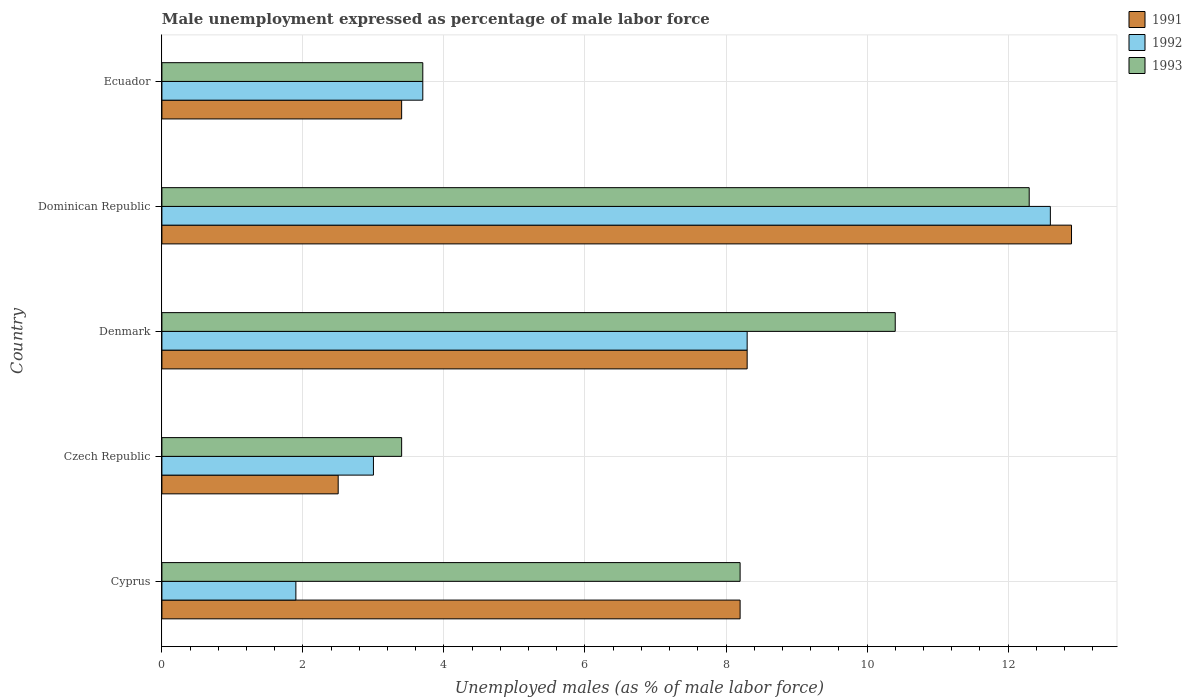How many different coloured bars are there?
Give a very brief answer. 3. How many bars are there on the 3rd tick from the bottom?
Make the answer very short. 3. What is the label of the 2nd group of bars from the top?
Provide a short and direct response. Dominican Republic. What is the unemployment in males in in 1992 in Cyprus?
Make the answer very short. 1.9. Across all countries, what is the maximum unemployment in males in in 1993?
Give a very brief answer. 12.3. In which country was the unemployment in males in in 1993 maximum?
Ensure brevity in your answer.  Dominican Republic. In which country was the unemployment in males in in 1993 minimum?
Provide a succinct answer. Czech Republic. What is the total unemployment in males in in 1992 in the graph?
Your response must be concise. 29.5. What is the difference between the unemployment in males in in 1991 in Denmark and that in Ecuador?
Give a very brief answer. 4.9. What is the difference between the unemployment in males in in 1993 in Czech Republic and the unemployment in males in in 1992 in Ecuador?
Make the answer very short. -0.3. What is the average unemployment in males in in 1993 per country?
Your answer should be very brief. 7.6. What is the difference between the unemployment in males in in 1991 and unemployment in males in in 1992 in Dominican Republic?
Offer a very short reply. 0.3. What is the ratio of the unemployment in males in in 1993 in Cyprus to that in Denmark?
Ensure brevity in your answer.  0.79. Is the unemployment in males in in 1993 in Denmark less than that in Ecuador?
Provide a short and direct response. No. What is the difference between the highest and the second highest unemployment in males in in 1993?
Ensure brevity in your answer.  1.9. What is the difference between the highest and the lowest unemployment in males in in 1993?
Provide a short and direct response. 8.9. Is the sum of the unemployment in males in in 1992 in Cyprus and Ecuador greater than the maximum unemployment in males in in 1993 across all countries?
Offer a very short reply. No. Is it the case that in every country, the sum of the unemployment in males in in 1991 and unemployment in males in in 1992 is greater than the unemployment in males in in 1993?
Keep it short and to the point. Yes. What is the difference between two consecutive major ticks on the X-axis?
Your response must be concise. 2. Where does the legend appear in the graph?
Offer a very short reply. Top right. What is the title of the graph?
Offer a very short reply. Male unemployment expressed as percentage of male labor force. What is the label or title of the X-axis?
Provide a succinct answer. Unemployed males (as % of male labor force). What is the Unemployed males (as % of male labor force) of 1991 in Cyprus?
Provide a short and direct response. 8.2. What is the Unemployed males (as % of male labor force) of 1992 in Cyprus?
Keep it short and to the point. 1.9. What is the Unemployed males (as % of male labor force) in 1993 in Cyprus?
Give a very brief answer. 8.2. What is the Unemployed males (as % of male labor force) of 1991 in Czech Republic?
Keep it short and to the point. 2.5. What is the Unemployed males (as % of male labor force) of 1993 in Czech Republic?
Ensure brevity in your answer.  3.4. What is the Unemployed males (as % of male labor force) in 1991 in Denmark?
Your answer should be compact. 8.3. What is the Unemployed males (as % of male labor force) in 1992 in Denmark?
Your response must be concise. 8.3. What is the Unemployed males (as % of male labor force) of 1993 in Denmark?
Ensure brevity in your answer.  10.4. What is the Unemployed males (as % of male labor force) in 1991 in Dominican Republic?
Make the answer very short. 12.9. What is the Unemployed males (as % of male labor force) in 1992 in Dominican Republic?
Your response must be concise. 12.6. What is the Unemployed males (as % of male labor force) of 1993 in Dominican Republic?
Provide a succinct answer. 12.3. What is the Unemployed males (as % of male labor force) of 1991 in Ecuador?
Make the answer very short. 3.4. What is the Unemployed males (as % of male labor force) of 1992 in Ecuador?
Your answer should be very brief. 3.7. What is the Unemployed males (as % of male labor force) of 1993 in Ecuador?
Provide a short and direct response. 3.7. Across all countries, what is the maximum Unemployed males (as % of male labor force) of 1991?
Provide a succinct answer. 12.9. Across all countries, what is the maximum Unemployed males (as % of male labor force) in 1992?
Your answer should be compact. 12.6. Across all countries, what is the maximum Unemployed males (as % of male labor force) in 1993?
Your answer should be compact. 12.3. Across all countries, what is the minimum Unemployed males (as % of male labor force) in 1991?
Your answer should be very brief. 2.5. Across all countries, what is the minimum Unemployed males (as % of male labor force) in 1992?
Keep it short and to the point. 1.9. Across all countries, what is the minimum Unemployed males (as % of male labor force) in 1993?
Give a very brief answer. 3.4. What is the total Unemployed males (as % of male labor force) of 1991 in the graph?
Ensure brevity in your answer.  35.3. What is the total Unemployed males (as % of male labor force) in 1992 in the graph?
Keep it short and to the point. 29.5. What is the total Unemployed males (as % of male labor force) of 1993 in the graph?
Your answer should be compact. 38. What is the difference between the Unemployed males (as % of male labor force) of 1992 in Cyprus and that in Czech Republic?
Ensure brevity in your answer.  -1.1. What is the difference between the Unemployed males (as % of male labor force) in 1993 in Cyprus and that in Czech Republic?
Your response must be concise. 4.8. What is the difference between the Unemployed males (as % of male labor force) in 1991 in Cyprus and that in Denmark?
Your response must be concise. -0.1. What is the difference between the Unemployed males (as % of male labor force) in 1991 in Cyprus and that in Dominican Republic?
Your response must be concise. -4.7. What is the difference between the Unemployed males (as % of male labor force) in 1992 in Cyprus and that in Dominican Republic?
Make the answer very short. -10.7. What is the difference between the Unemployed males (as % of male labor force) of 1992 in Cyprus and that in Ecuador?
Offer a very short reply. -1.8. What is the difference between the Unemployed males (as % of male labor force) of 1993 in Cyprus and that in Ecuador?
Offer a terse response. 4.5. What is the difference between the Unemployed males (as % of male labor force) of 1991 in Czech Republic and that in Denmark?
Your answer should be very brief. -5.8. What is the difference between the Unemployed males (as % of male labor force) in 1993 in Czech Republic and that in Denmark?
Make the answer very short. -7. What is the difference between the Unemployed males (as % of male labor force) of 1991 in Czech Republic and that in Dominican Republic?
Give a very brief answer. -10.4. What is the difference between the Unemployed males (as % of male labor force) in 1993 in Czech Republic and that in Dominican Republic?
Offer a very short reply. -8.9. What is the difference between the Unemployed males (as % of male labor force) in 1993 in Czech Republic and that in Ecuador?
Offer a very short reply. -0.3. What is the difference between the Unemployed males (as % of male labor force) of 1992 in Denmark and that in Dominican Republic?
Keep it short and to the point. -4.3. What is the difference between the Unemployed males (as % of male labor force) in 1991 in Denmark and that in Ecuador?
Ensure brevity in your answer.  4.9. What is the difference between the Unemployed males (as % of male labor force) in 1992 in Denmark and that in Ecuador?
Your answer should be very brief. 4.6. What is the difference between the Unemployed males (as % of male labor force) of 1992 in Dominican Republic and that in Ecuador?
Ensure brevity in your answer.  8.9. What is the difference between the Unemployed males (as % of male labor force) of 1991 in Cyprus and the Unemployed males (as % of male labor force) of 1993 in Czech Republic?
Provide a succinct answer. 4.8. What is the difference between the Unemployed males (as % of male labor force) of 1992 in Cyprus and the Unemployed males (as % of male labor force) of 1993 in Czech Republic?
Keep it short and to the point. -1.5. What is the difference between the Unemployed males (as % of male labor force) of 1991 in Cyprus and the Unemployed males (as % of male labor force) of 1992 in Denmark?
Offer a terse response. -0.1. What is the difference between the Unemployed males (as % of male labor force) in 1991 in Cyprus and the Unemployed males (as % of male labor force) in 1993 in Denmark?
Offer a very short reply. -2.2. What is the difference between the Unemployed males (as % of male labor force) in 1991 in Cyprus and the Unemployed males (as % of male labor force) in 1992 in Dominican Republic?
Make the answer very short. -4.4. What is the difference between the Unemployed males (as % of male labor force) of 1991 in Czech Republic and the Unemployed males (as % of male labor force) of 1992 in Denmark?
Offer a very short reply. -5.8. What is the difference between the Unemployed males (as % of male labor force) in 1992 in Czech Republic and the Unemployed males (as % of male labor force) in 1993 in Denmark?
Keep it short and to the point. -7.4. What is the difference between the Unemployed males (as % of male labor force) of 1991 in Czech Republic and the Unemployed males (as % of male labor force) of 1992 in Dominican Republic?
Ensure brevity in your answer.  -10.1. What is the difference between the Unemployed males (as % of male labor force) in 1991 in Czech Republic and the Unemployed males (as % of male labor force) in 1993 in Dominican Republic?
Make the answer very short. -9.8. What is the difference between the Unemployed males (as % of male labor force) of 1992 in Czech Republic and the Unemployed males (as % of male labor force) of 1993 in Ecuador?
Ensure brevity in your answer.  -0.7. What is the difference between the Unemployed males (as % of male labor force) in 1991 in Denmark and the Unemployed males (as % of male labor force) in 1993 in Ecuador?
Keep it short and to the point. 4.6. What is the average Unemployed males (as % of male labor force) of 1991 per country?
Your response must be concise. 7.06. What is the average Unemployed males (as % of male labor force) of 1992 per country?
Give a very brief answer. 5.9. What is the average Unemployed males (as % of male labor force) in 1993 per country?
Provide a succinct answer. 7.6. What is the difference between the Unemployed males (as % of male labor force) in 1991 and Unemployed males (as % of male labor force) in 1993 in Denmark?
Your answer should be very brief. -2.1. What is the difference between the Unemployed males (as % of male labor force) of 1992 and Unemployed males (as % of male labor force) of 1993 in Denmark?
Your response must be concise. -2.1. What is the difference between the Unemployed males (as % of male labor force) in 1991 and Unemployed males (as % of male labor force) in 1992 in Dominican Republic?
Provide a short and direct response. 0.3. What is the difference between the Unemployed males (as % of male labor force) of 1991 and Unemployed males (as % of male labor force) of 1992 in Ecuador?
Provide a short and direct response. -0.3. What is the difference between the Unemployed males (as % of male labor force) of 1991 and Unemployed males (as % of male labor force) of 1993 in Ecuador?
Offer a very short reply. -0.3. What is the ratio of the Unemployed males (as % of male labor force) in 1991 in Cyprus to that in Czech Republic?
Provide a short and direct response. 3.28. What is the ratio of the Unemployed males (as % of male labor force) of 1992 in Cyprus to that in Czech Republic?
Keep it short and to the point. 0.63. What is the ratio of the Unemployed males (as % of male labor force) in 1993 in Cyprus to that in Czech Republic?
Your answer should be compact. 2.41. What is the ratio of the Unemployed males (as % of male labor force) of 1991 in Cyprus to that in Denmark?
Provide a succinct answer. 0.99. What is the ratio of the Unemployed males (as % of male labor force) in 1992 in Cyprus to that in Denmark?
Give a very brief answer. 0.23. What is the ratio of the Unemployed males (as % of male labor force) of 1993 in Cyprus to that in Denmark?
Your response must be concise. 0.79. What is the ratio of the Unemployed males (as % of male labor force) in 1991 in Cyprus to that in Dominican Republic?
Provide a succinct answer. 0.64. What is the ratio of the Unemployed males (as % of male labor force) in 1992 in Cyprus to that in Dominican Republic?
Ensure brevity in your answer.  0.15. What is the ratio of the Unemployed males (as % of male labor force) of 1991 in Cyprus to that in Ecuador?
Your answer should be compact. 2.41. What is the ratio of the Unemployed males (as % of male labor force) of 1992 in Cyprus to that in Ecuador?
Your answer should be very brief. 0.51. What is the ratio of the Unemployed males (as % of male labor force) of 1993 in Cyprus to that in Ecuador?
Provide a succinct answer. 2.22. What is the ratio of the Unemployed males (as % of male labor force) of 1991 in Czech Republic to that in Denmark?
Give a very brief answer. 0.3. What is the ratio of the Unemployed males (as % of male labor force) in 1992 in Czech Republic to that in Denmark?
Your answer should be very brief. 0.36. What is the ratio of the Unemployed males (as % of male labor force) in 1993 in Czech Republic to that in Denmark?
Ensure brevity in your answer.  0.33. What is the ratio of the Unemployed males (as % of male labor force) in 1991 in Czech Republic to that in Dominican Republic?
Your answer should be compact. 0.19. What is the ratio of the Unemployed males (as % of male labor force) in 1992 in Czech Republic to that in Dominican Republic?
Keep it short and to the point. 0.24. What is the ratio of the Unemployed males (as % of male labor force) of 1993 in Czech Republic to that in Dominican Republic?
Ensure brevity in your answer.  0.28. What is the ratio of the Unemployed males (as % of male labor force) of 1991 in Czech Republic to that in Ecuador?
Provide a succinct answer. 0.74. What is the ratio of the Unemployed males (as % of male labor force) in 1992 in Czech Republic to that in Ecuador?
Your response must be concise. 0.81. What is the ratio of the Unemployed males (as % of male labor force) in 1993 in Czech Republic to that in Ecuador?
Provide a succinct answer. 0.92. What is the ratio of the Unemployed males (as % of male labor force) in 1991 in Denmark to that in Dominican Republic?
Your response must be concise. 0.64. What is the ratio of the Unemployed males (as % of male labor force) of 1992 in Denmark to that in Dominican Republic?
Ensure brevity in your answer.  0.66. What is the ratio of the Unemployed males (as % of male labor force) of 1993 in Denmark to that in Dominican Republic?
Give a very brief answer. 0.85. What is the ratio of the Unemployed males (as % of male labor force) in 1991 in Denmark to that in Ecuador?
Your answer should be compact. 2.44. What is the ratio of the Unemployed males (as % of male labor force) of 1992 in Denmark to that in Ecuador?
Offer a very short reply. 2.24. What is the ratio of the Unemployed males (as % of male labor force) of 1993 in Denmark to that in Ecuador?
Make the answer very short. 2.81. What is the ratio of the Unemployed males (as % of male labor force) of 1991 in Dominican Republic to that in Ecuador?
Give a very brief answer. 3.79. What is the ratio of the Unemployed males (as % of male labor force) of 1992 in Dominican Republic to that in Ecuador?
Provide a short and direct response. 3.41. What is the ratio of the Unemployed males (as % of male labor force) in 1993 in Dominican Republic to that in Ecuador?
Provide a short and direct response. 3.32. What is the difference between the highest and the second highest Unemployed males (as % of male labor force) of 1991?
Your answer should be compact. 4.6. What is the difference between the highest and the second highest Unemployed males (as % of male labor force) of 1992?
Your answer should be very brief. 4.3. What is the difference between the highest and the lowest Unemployed males (as % of male labor force) in 1991?
Provide a short and direct response. 10.4. What is the difference between the highest and the lowest Unemployed males (as % of male labor force) in 1992?
Your answer should be compact. 10.7. What is the difference between the highest and the lowest Unemployed males (as % of male labor force) of 1993?
Your answer should be very brief. 8.9. 